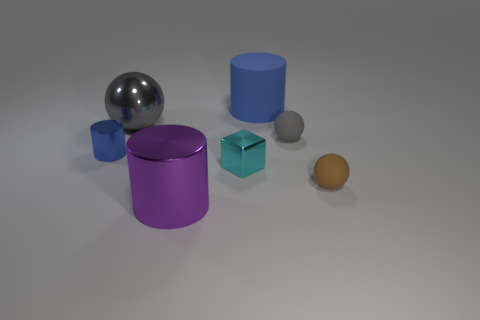There is a thing that is the same color as the big matte cylinder; what size is it?
Your answer should be compact. Small. What shape is the thing that is the same color as the big sphere?
Make the answer very short. Sphere. There is another cylinder that is the same size as the matte cylinder; what color is it?
Your answer should be compact. Purple. Are there any small cylinders of the same color as the big ball?
Ensure brevity in your answer.  No. What number of things are metal cubes left of the rubber cylinder or yellow rubber blocks?
Ensure brevity in your answer.  1. How many other objects are the same size as the gray shiny sphere?
Your answer should be very brief. 2. There is a blue object that is behind the tiny matte object behind the metallic cylinder that is behind the metal block; what is it made of?
Provide a short and direct response. Rubber. How many balls are tiny gray things or blue objects?
Your response must be concise. 1. Is there anything else that is the same shape as the large gray shiny object?
Provide a short and direct response. Yes. Is the number of large objects behind the small gray rubber ball greater than the number of matte spheres that are left of the brown sphere?
Ensure brevity in your answer.  Yes. 